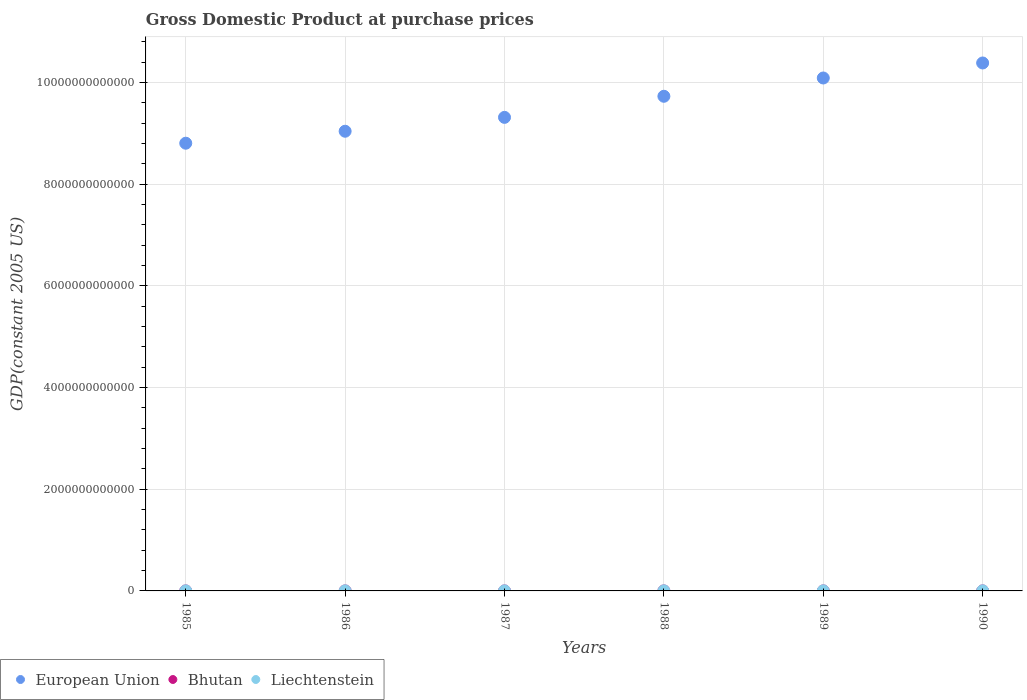What is the GDP at purchase prices in Bhutan in 1988?
Make the answer very short. 2.89e+08. Across all years, what is the maximum GDP at purchase prices in Liechtenstein?
Provide a succinct answer. 2.01e+09. Across all years, what is the minimum GDP at purchase prices in Liechtenstein?
Provide a succinct answer. 1.56e+09. In which year was the GDP at purchase prices in European Union minimum?
Make the answer very short. 1985. What is the total GDP at purchase prices in European Union in the graph?
Provide a short and direct response. 5.74e+13. What is the difference between the GDP at purchase prices in European Union in 1985 and that in 1988?
Provide a short and direct response. -9.23e+11. What is the difference between the GDP at purchase prices in Liechtenstein in 1988 and the GDP at purchase prices in Bhutan in 1990?
Make the answer very short. 1.53e+09. What is the average GDP at purchase prices in Bhutan per year?
Offer a very short reply. 2.71e+08. In the year 1990, what is the difference between the GDP at purchase prices in Bhutan and GDP at purchase prices in Liechtenstein?
Keep it short and to the point. -1.66e+09. What is the ratio of the GDP at purchase prices in Bhutan in 1985 to that in 1987?
Ensure brevity in your answer.  0.7. What is the difference between the highest and the second highest GDP at purchase prices in Liechtenstein?
Provide a succinct answer. 4.42e+07. What is the difference between the highest and the lowest GDP at purchase prices in European Union?
Your answer should be compact. 1.58e+12. In how many years, is the GDP at purchase prices in European Union greater than the average GDP at purchase prices in European Union taken over all years?
Keep it short and to the point. 3. Is the sum of the GDP at purchase prices in Liechtenstein in 1985 and 1988 greater than the maximum GDP at purchase prices in Bhutan across all years?
Your answer should be compact. Yes. Is the GDP at purchase prices in Bhutan strictly greater than the GDP at purchase prices in European Union over the years?
Make the answer very short. No. Is the GDP at purchase prices in European Union strictly less than the GDP at purchase prices in Bhutan over the years?
Your answer should be very brief. No. How many dotlines are there?
Give a very brief answer. 3. What is the difference between two consecutive major ticks on the Y-axis?
Your response must be concise. 2.00e+12. Are the values on the major ticks of Y-axis written in scientific E-notation?
Offer a very short reply. No. Does the graph contain any zero values?
Give a very brief answer. No. Does the graph contain grids?
Offer a terse response. Yes. Where does the legend appear in the graph?
Offer a very short reply. Bottom left. How many legend labels are there?
Your answer should be compact. 3. What is the title of the graph?
Your answer should be very brief. Gross Domestic Product at purchase prices. Does "Cambodia" appear as one of the legend labels in the graph?
Provide a short and direct response. No. What is the label or title of the X-axis?
Give a very brief answer. Years. What is the label or title of the Y-axis?
Make the answer very short. GDP(constant 2005 US). What is the GDP(constant 2005 US) of European Union in 1985?
Keep it short and to the point. 8.80e+12. What is the GDP(constant 2005 US) of Bhutan in 1985?
Provide a succinct answer. 1.92e+08. What is the GDP(constant 2005 US) in Liechtenstein in 1985?
Make the answer very short. 1.56e+09. What is the GDP(constant 2005 US) of European Union in 1986?
Offer a terse response. 9.04e+12. What is the GDP(constant 2005 US) of Bhutan in 1986?
Offer a terse response. 2.14e+08. What is the GDP(constant 2005 US) in Liechtenstein in 1986?
Make the answer very short. 1.63e+09. What is the GDP(constant 2005 US) in European Union in 1987?
Ensure brevity in your answer.  9.31e+12. What is the GDP(constant 2005 US) in Bhutan in 1987?
Ensure brevity in your answer.  2.75e+08. What is the GDP(constant 2005 US) of Liechtenstein in 1987?
Ensure brevity in your answer.  1.78e+09. What is the GDP(constant 2005 US) in European Union in 1988?
Ensure brevity in your answer.  9.73e+12. What is the GDP(constant 2005 US) of Bhutan in 1988?
Provide a short and direct response. 2.89e+08. What is the GDP(constant 2005 US) of Liechtenstein in 1988?
Ensure brevity in your answer.  1.88e+09. What is the GDP(constant 2005 US) in European Union in 1989?
Keep it short and to the point. 1.01e+13. What is the GDP(constant 2005 US) of Bhutan in 1989?
Give a very brief answer. 3.11e+08. What is the GDP(constant 2005 US) in Liechtenstein in 1989?
Your response must be concise. 1.96e+09. What is the GDP(constant 2005 US) of European Union in 1990?
Your answer should be very brief. 1.04e+13. What is the GDP(constant 2005 US) of Bhutan in 1990?
Offer a terse response. 3.45e+08. What is the GDP(constant 2005 US) in Liechtenstein in 1990?
Provide a succinct answer. 2.01e+09. Across all years, what is the maximum GDP(constant 2005 US) of European Union?
Make the answer very short. 1.04e+13. Across all years, what is the maximum GDP(constant 2005 US) of Bhutan?
Your answer should be very brief. 3.45e+08. Across all years, what is the maximum GDP(constant 2005 US) of Liechtenstein?
Offer a terse response. 2.01e+09. Across all years, what is the minimum GDP(constant 2005 US) in European Union?
Keep it short and to the point. 8.80e+12. Across all years, what is the minimum GDP(constant 2005 US) of Bhutan?
Your answer should be very brief. 1.92e+08. Across all years, what is the minimum GDP(constant 2005 US) in Liechtenstein?
Your response must be concise. 1.56e+09. What is the total GDP(constant 2005 US) of European Union in the graph?
Your answer should be compact. 5.74e+13. What is the total GDP(constant 2005 US) in Bhutan in the graph?
Ensure brevity in your answer.  1.63e+09. What is the total GDP(constant 2005 US) of Liechtenstein in the graph?
Your answer should be compact. 1.08e+1. What is the difference between the GDP(constant 2005 US) in European Union in 1985 and that in 1986?
Provide a short and direct response. -2.35e+11. What is the difference between the GDP(constant 2005 US) in Bhutan in 1985 and that in 1986?
Keep it short and to the point. -2.25e+07. What is the difference between the GDP(constant 2005 US) in Liechtenstein in 1985 and that in 1986?
Offer a very short reply. -6.26e+07. What is the difference between the GDP(constant 2005 US) in European Union in 1985 and that in 1987?
Make the answer very short. -5.08e+11. What is the difference between the GDP(constant 2005 US) of Bhutan in 1985 and that in 1987?
Your answer should be very brief. -8.39e+07. What is the difference between the GDP(constant 2005 US) in Liechtenstein in 1985 and that in 1987?
Keep it short and to the point. -2.13e+08. What is the difference between the GDP(constant 2005 US) in European Union in 1985 and that in 1988?
Provide a short and direct response. -9.23e+11. What is the difference between the GDP(constant 2005 US) of Bhutan in 1985 and that in 1988?
Ensure brevity in your answer.  -9.76e+07. What is the difference between the GDP(constant 2005 US) of Liechtenstein in 1985 and that in 1988?
Offer a terse response. -3.13e+08. What is the difference between the GDP(constant 2005 US) of European Union in 1985 and that in 1989?
Make the answer very short. -1.28e+12. What is the difference between the GDP(constant 2005 US) of Bhutan in 1985 and that in 1989?
Offer a terse response. -1.19e+08. What is the difference between the GDP(constant 2005 US) in Liechtenstein in 1985 and that in 1989?
Offer a terse response. -3.97e+08. What is the difference between the GDP(constant 2005 US) of European Union in 1985 and that in 1990?
Your answer should be compact. -1.58e+12. What is the difference between the GDP(constant 2005 US) of Bhutan in 1985 and that in 1990?
Your response must be concise. -1.53e+08. What is the difference between the GDP(constant 2005 US) of Liechtenstein in 1985 and that in 1990?
Offer a terse response. -4.41e+08. What is the difference between the GDP(constant 2005 US) of European Union in 1986 and that in 1987?
Give a very brief answer. -2.73e+11. What is the difference between the GDP(constant 2005 US) in Bhutan in 1986 and that in 1987?
Offer a very short reply. -6.14e+07. What is the difference between the GDP(constant 2005 US) of Liechtenstein in 1986 and that in 1987?
Keep it short and to the point. -1.50e+08. What is the difference between the GDP(constant 2005 US) of European Union in 1986 and that in 1988?
Offer a terse response. -6.88e+11. What is the difference between the GDP(constant 2005 US) of Bhutan in 1986 and that in 1988?
Offer a terse response. -7.52e+07. What is the difference between the GDP(constant 2005 US) in Liechtenstein in 1986 and that in 1988?
Make the answer very short. -2.50e+08. What is the difference between the GDP(constant 2005 US) in European Union in 1986 and that in 1989?
Your answer should be very brief. -1.05e+12. What is the difference between the GDP(constant 2005 US) in Bhutan in 1986 and that in 1989?
Your response must be concise. -9.67e+07. What is the difference between the GDP(constant 2005 US) in Liechtenstein in 1986 and that in 1989?
Your answer should be compact. -3.35e+08. What is the difference between the GDP(constant 2005 US) in European Union in 1986 and that in 1990?
Make the answer very short. -1.34e+12. What is the difference between the GDP(constant 2005 US) in Bhutan in 1986 and that in 1990?
Keep it short and to the point. -1.30e+08. What is the difference between the GDP(constant 2005 US) of Liechtenstein in 1986 and that in 1990?
Your response must be concise. -3.79e+08. What is the difference between the GDP(constant 2005 US) of European Union in 1987 and that in 1988?
Keep it short and to the point. -4.15e+11. What is the difference between the GDP(constant 2005 US) in Bhutan in 1987 and that in 1988?
Keep it short and to the point. -1.37e+07. What is the difference between the GDP(constant 2005 US) in Liechtenstein in 1987 and that in 1988?
Offer a terse response. -1.00e+08. What is the difference between the GDP(constant 2005 US) of European Union in 1987 and that in 1989?
Offer a terse response. -7.74e+11. What is the difference between the GDP(constant 2005 US) in Bhutan in 1987 and that in 1989?
Provide a succinct answer. -3.52e+07. What is the difference between the GDP(constant 2005 US) in Liechtenstein in 1987 and that in 1989?
Give a very brief answer. -1.84e+08. What is the difference between the GDP(constant 2005 US) in European Union in 1987 and that in 1990?
Offer a terse response. -1.07e+12. What is the difference between the GDP(constant 2005 US) in Bhutan in 1987 and that in 1990?
Provide a succinct answer. -6.90e+07. What is the difference between the GDP(constant 2005 US) of Liechtenstein in 1987 and that in 1990?
Ensure brevity in your answer.  -2.29e+08. What is the difference between the GDP(constant 2005 US) in European Union in 1988 and that in 1989?
Provide a succinct answer. -3.60e+11. What is the difference between the GDP(constant 2005 US) of Bhutan in 1988 and that in 1989?
Make the answer very short. -2.15e+07. What is the difference between the GDP(constant 2005 US) of Liechtenstein in 1988 and that in 1989?
Your response must be concise. -8.43e+07. What is the difference between the GDP(constant 2005 US) of European Union in 1988 and that in 1990?
Offer a very short reply. -6.55e+11. What is the difference between the GDP(constant 2005 US) of Bhutan in 1988 and that in 1990?
Provide a short and direct response. -5.53e+07. What is the difference between the GDP(constant 2005 US) of Liechtenstein in 1988 and that in 1990?
Your response must be concise. -1.28e+08. What is the difference between the GDP(constant 2005 US) in European Union in 1989 and that in 1990?
Offer a very short reply. -2.95e+11. What is the difference between the GDP(constant 2005 US) of Bhutan in 1989 and that in 1990?
Your answer should be compact. -3.38e+07. What is the difference between the GDP(constant 2005 US) in Liechtenstein in 1989 and that in 1990?
Your answer should be compact. -4.42e+07. What is the difference between the GDP(constant 2005 US) in European Union in 1985 and the GDP(constant 2005 US) in Bhutan in 1986?
Ensure brevity in your answer.  8.80e+12. What is the difference between the GDP(constant 2005 US) in European Union in 1985 and the GDP(constant 2005 US) in Liechtenstein in 1986?
Your answer should be compact. 8.80e+12. What is the difference between the GDP(constant 2005 US) of Bhutan in 1985 and the GDP(constant 2005 US) of Liechtenstein in 1986?
Your response must be concise. -1.44e+09. What is the difference between the GDP(constant 2005 US) of European Union in 1985 and the GDP(constant 2005 US) of Bhutan in 1987?
Ensure brevity in your answer.  8.80e+12. What is the difference between the GDP(constant 2005 US) of European Union in 1985 and the GDP(constant 2005 US) of Liechtenstein in 1987?
Offer a terse response. 8.80e+12. What is the difference between the GDP(constant 2005 US) in Bhutan in 1985 and the GDP(constant 2005 US) in Liechtenstein in 1987?
Offer a very short reply. -1.59e+09. What is the difference between the GDP(constant 2005 US) in European Union in 1985 and the GDP(constant 2005 US) in Bhutan in 1988?
Your answer should be compact. 8.80e+12. What is the difference between the GDP(constant 2005 US) in European Union in 1985 and the GDP(constant 2005 US) in Liechtenstein in 1988?
Provide a succinct answer. 8.80e+12. What is the difference between the GDP(constant 2005 US) of Bhutan in 1985 and the GDP(constant 2005 US) of Liechtenstein in 1988?
Your answer should be very brief. -1.69e+09. What is the difference between the GDP(constant 2005 US) in European Union in 1985 and the GDP(constant 2005 US) in Bhutan in 1989?
Give a very brief answer. 8.80e+12. What is the difference between the GDP(constant 2005 US) in European Union in 1985 and the GDP(constant 2005 US) in Liechtenstein in 1989?
Offer a very short reply. 8.80e+12. What is the difference between the GDP(constant 2005 US) of Bhutan in 1985 and the GDP(constant 2005 US) of Liechtenstein in 1989?
Your response must be concise. -1.77e+09. What is the difference between the GDP(constant 2005 US) of European Union in 1985 and the GDP(constant 2005 US) of Bhutan in 1990?
Your answer should be very brief. 8.80e+12. What is the difference between the GDP(constant 2005 US) in European Union in 1985 and the GDP(constant 2005 US) in Liechtenstein in 1990?
Your answer should be compact. 8.80e+12. What is the difference between the GDP(constant 2005 US) of Bhutan in 1985 and the GDP(constant 2005 US) of Liechtenstein in 1990?
Your answer should be compact. -1.81e+09. What is the difference between the GDP(constant 2005 US) in European Union in 1986 and the GDP(constant 2005 US) in Bhutan in 1987?
Your answer should be compact. 9.04e+12. What is the difference between the GDP(constant 2005 US) in European Union in 1986 and the GDP(constant 2005 US) in Liechtenstein in 1987?
Keep it short and to the point. 9.04e+12. What is the difference between the GDP(constant 2005 US) in Bhutan in 1986 and the GDP(constant 2005 US) in Liechtenstein in 1987?
Make the answer very short. -1.56e+09. What is the difference between the GDP(constant 2005 US) in European Union in 1986 and the GDP(constant 2005 US) in Bhutan in 1988?
Your response must be concise. 9.04e+12. What is the difference between the GDP(constant 2005 US) of European Union in 1986 and the GDP(constant 2005 US) of Liechtenstein in 1988?
Give a very brief answer. 9.04e+12. What is the difference between the GDP(constant 2005 US) in Bhutan in 1986 and the GDP(constant 2005 US) in Liechtenstein in 1988?
Offer a very short reply. -1.66e+09. What is the difference between the GDP(constant 2005 US) in European Union in 1986 and the GDP(constant 2005 US) in Bhutan in 1989?
Ensure brevity in your answer.  9.04e+12. What is the difference between the GDP(constant 2005 US) in European Union in 1986 and the GDP(constant 2005 US) in Liechtenstein in 1989?
Make the answer very short. 9.04e+12. What is the difference between the GDP(constant 2005 US) of Bhutan in 1986 and the GDP(constant 2005 US) of Liechtenstein in 1989?
Your answer should be very brief. -1.75e+09. What is the difference between the GDP(constant 2005 US) of European Union in 1986 and the GDP(constant 2005 US) of Bhutan in 1990?
Offer a very short reply. 9.04e+12. What is the difference between the GDP(constant 2005 US) in European Union in 1986 and the GDP(constant 2005 US) in Liechtenstein in 1990?
Your response must be concise. 9.04e+12. What is the difference between the GDP(constant 2005 US) in Bhutan in 1986 and the GDP(constant 2005 US) in Liechtenstein in 1990?
Your answer should be compact. -1.79e+09. What is the difference between the GDP(constant 2005 US) of European Union in 1987 and the GDP(constant 2005 US) of Bhutan in 1988?
Your answer should be very brief. 9.31e+12. What is the difference between the GDP(constant 2005 US) in European Union in 1987 and the GDP(constant 2005 US) in Liechtenstein in 1988?
Offer a very short reply. 9.31e+12. What is the difference between the GDP(constant 2005 US) of Bhutan in 1987 and the GDP(constant 2005 US) of Liechtenstein in 1988?
Ensure brevity in your answer.  -1.60e+09. What is the difference between the GDP(constant 2005 US) in European Union in 1987 and the GDP(constant 2005 US) in Bhutan in 1989?
Offer a terse response. 9.31e+12. What is the difference between the GDP(constant 2005 US) of European Union in 1987 and the GDP(constant 2005 US) of Liechtenstein in 1989?
Make the answer very short. 9.31e+12. What is the difference between the GDP(constant 2005 US) of Bhutan in 1987 and the GDP(constant 2005 US) of Liechtenstein in 1989?
Ensure brevity in your answer.  -1.69e+09. What is the difference between the GDP(constant 2005 US) of European Union in 1987 and the GDP(constant 2005 US) of Bhutan in 1990?
Give a very brief answer. 9.31e+12. What is the difference between the GDP(constant 2005 US) in European Union in 1987 and the GDP(constant 2005 US) in Liechtenstein in 1990?
Provide a short and direct response. 9.31e+12. What is the difference between the GDP(constant 2005 US) of Bhutan in 1987 and the GDP(constant 2005 US) of Liechtenstein in 1990?
Offer a terse response. -1.73e+09. What is the difference between the GDP(constant 2005 US) of European Union in 1988 and the GDP(constant 2005 US) of Bhutan in 1989?
Your answer should be compact. 9.73e+12. What is the difference between the GDP(constant 2005 US) of European Union in 1988 and the GDP(constant 2005 US) of Liechtenstein in 1989?
Ensure brevity in your answer.  9.73e+12. What is the difference between the GDP(constant 2005 US) of Bhutan in 1988 and the GDP(constant 2005 US) of Liechtenstein in 1989?
Offer a very short reply. -1.67e+09. What is the difference between the GDP(constant 2005 US) in European Union in 1988 and the GDP(constant 2005 US) in Bhutan in 1990?
Your answer should be compact. 9.73e+12. What is the difference between the GDP(constant 2005 US) in European Union in 1988 and the GDP(constant 2005 US) in Liechtenstein in 1990?
Keep it short and to the point. 9.73e+12. What is the difference between the GDP(constant 2005 US) in Bhutan in 1988 and the GDP(constant 2005 US) in Liechtenstein in 1990?
Your answer should be very brief. -1.72e+09. What is the difference between the GDP(constant 2005 US) of European Union in 1989 and the GDP(constant 2005 US) of Bhutan in 1990?
Your answer should be very brief. 1.01e+13. What is the difference between the GDP(constant 2005 US) of European Union in 1989 and the GDP(constant 2005 US) of Liechtenstein in 1990?
Give a very brief answer. 1.01e+13. What is the difference between the GDP(constant 2005 US) of Bhutan in 1989 and the GDP(constant 2005 US) of Liechtenstein in 1990?
Provide a succinct answer. -1.69e+09. What is the average GDP(constant 2005 US) of European Union per year?
Your answer should be compact. 9.56e+12. What is the average GDP(constant 2005 US) in Bhutan per year?
Make the answer very short. 2.71e+08. What is the average GDP(constant 2005 US) of Liechtenstein per year?
Ensure brevity in your answer.  1.80e+09. In the year 1985, what is the difference between the GDP(constant 2005 US) in European Union and GDP(constant 2005 US) in Bhutan?
Offer a terse response. 8.80e+12. In the year 1985, what is the difference between the GDP(constant 2005 US) in European Union and GDP(constant 2005 US) in Liechtenstein?
Provide a short and direct response. 8.80e+12. In the year 1985, what is the difference between the GDP(constant 2005 US) of Bhutan and GDP(constant 2005 US) of Liechtenstein?
Ensure brevity in your answer.  -1.37e+09. In the year 1986, what is the difference between the GDP(constant 2005 US) in European Union and GDP(constant 2005 US) in Bhutan?
Keep it short and to the point. 9.04e+12. In the year 1986, what is the difference between the GDP(constant 2005 US) in European Union and GDP(constant 2005 US) in Liechtenstein?
Your answer should be very brief. 9.04e+12. In the year 1986, what is the difference between the GDP(constant 2005 US) in Bhutan and GDP(constant 2005 US) in Liechtenstein?
Your response must be concise. -1.41e+09. In the year 1987, what is the difference between the GDP(constant 2005 US) of European Union and GDP(constant 2005 US) of Bhutan?
Provide a succinct answer. 9.31e+12. In the year 1987, what is the difference between the GDP(constant 2005 US) in European Union and GDP(constant 2005 US) in Liechtenstein?
Make the answer very short. 9.31e+12. In the year 1987, what is the difference between the GDP(constant 2005 US) in Bhutan and GDP(constant 2005 US) in Liechtenstein?
Keep it short and to the point. -1.50e+09. In the year 1988, what is the difference between the GDP(constant 2005 US) of European Union and GDP(constant 2005 US) of Bhutan?
Your answer should be compact. 9.73e+12. In the year 1988, what is the difference between the GDP(constant 2005 US) in European Union and GDP(constant 2005 US) in Liechtenstein?
Your response must be concise. 9.73e+12. In the year 1988, what is the difference between the GDP(constant 2005 US) in Bhutan and GDP(constant 2005 US) in Liechtenstein?
Offer a very short reply. -1.59e+09. In the year 1989, what is the difference between the GDP(constant 2005 US) in European Union and GDP(constant 2005 US) in Bhutan?
Provide a short and direct response. 1.01e+13. In the year 1989, what is the difference between the GDP(constant 2005 US) of European Union and GDP(constant 2005 US) of Liechtenstein?
Make the answer very short. 1.01e+13. In the year 1989, what is the difference between the GDP(constant 2005 US) in Bhutan and GDP(constant 2005 US) in Liechtenstein?
Give a very brief answer. -1.65e+09. In the year 1990, what is the difference between the GDP(constant 2005 US) of European Union and GDP(constant 2005 US) of Bhutan?
Keep it short and to the point. 1.04e+13. In the year 1990, what is the difference between the GDP(constant 2005 US) of European Union and GDP(constant 2005 US) of Liechtenstein?
Your answer should be compact. 1.04e+13. In the year 1990, what is the difference between the GDP(constant 2005 US) of Bhutan and GDP(constant 2005 US) of Liechtenstein?
Keep it short and to the point. -1.66e+09. What is the ratio of the GDP(constant 2005 US) in Bhutan in 1985 to that in 1986?
Your response must be concise. 0.9. What is the ratio of the GDP(constant 2005 US) in Liechtenstein in 1985 to that in 1986?
Your answer should be very brief. 0.96. What is the ratio of the GDP(constant 2005 US) in European Union in 1985 to that in 1987?
Provide a succinct answer. 0.95. What is the ratio of the GDP(constant 2005 US) in Bhutan in 1985 to that in 1987?
Give a very brief answer. 0.7. What is the ratio of the GDP(constant 2005 US) in Liechtenstein in 1985 to that in 1987?
Your response must be concise. 0.88. What is the ratio of the GDP(constant 2005 US) of European Union in 1985 to that in 1988?
Your response must be concise. 0.91. What is the ratio of the GDP(constant 2005 US) in Bhutan in 1985 to that in 1988?
Offer a terse response. 0.66. What is the ratio of the GDP(constant 2005 US) of European Union in 1985 to that in 1989?
Keep it short and to the point. 0.87. What is the ratio of the GDP(constant 2005 US) of Bhutan in 1985 to that in 1989?
Offer a very short reply. 0.62. What is the ratio of the GDP(constant 2005 US) in Liechtenstein in 1985 to that in 1989?
Ensure brevity in your answer.  0.8. What is the ratio of the GDP(constant 2005 US) in European Union in 1985 to that in 1990?
Keep it short and to the point. 0.85. What is the ratio of the GDP(constant 2005 US) of Bhutan in 1985 to that in 1990?
Provide a short and direct response. 0.56. What is the ratio of the GDP(constant 2005 US) of Liechtenstein in 1985 to that in 1990?
Offer a terse response. 0.78. What is the ratio of the GDP(constant 2005 US) of European Union in 1986 to that in 1987?
Your answer should be compact. 0.97. What is the ratio of the GDP(constant 2005 US) of Bhutan in 1986 to that in 1987?
Offer a very short reply. 0.78. What is the ratio of the GDP(constant 2005 US) of Liechtenstein in 1986 to that in 1987?
Make the answer very short. 0.92. What is the ratio of the GDP(constant 2005 US) of European Union in 1986 to that in 1988?
Your answer should be very brief. 0.93. What is the ratio of the GDP(constant 2005 US) of Bhutan in 1986 to that in 1988?
Offer a terse response. 0.74. What is the ratio of the GDP(constant 2005 US) in Liechtenstein in 1986 to that in 1988?
Provide a short and direct response. 0.87. What is the ratio of the GDP(constant 2005 US) in European Union in 1986 to that in 1989?
Give a very brief answer. 0.9. What is the ratio of the GDP(constant 2005 US) of Bhutan in 1986 to that in 1989?
Offer a terse response. 0.69. What is the ratio of the GDP(constant 2005 US) in Liechtenstein in 1986 to that in 1989?
Give a very brief answer. 0.83. What is the ratio of the GDP(constant 2005 US) in European Union in 1986 to that in 1990?
Your answer should be compact. 0.87. What is the ratio of the GDP(constant 2005 US) of Bhutan in 1986 to that in 1990?
Offer a terse response. 0.62. What is the ratio of the GDP(constant 2005 US) of Liechtenstein in 1986 to that in 1990?
Make the answer very short. 0.81. What is the ratio of the GDP(constant 2005 US) of European Union in 1987 to that in 1988?
Offer a very short reply. 0.96. What is the ratio of the GDP(constant 2005 US) of Bhutan in 1987 to that in 1988?
Your response must be concise. 0.95. What is the ratio of the GDP(constant 2005 US) in Liechtenstein in 1987 to that in 1988?
Provide a short and direct response. 0.95. What is the ratio of the GDP(constant 2005 US) in European Union in 1987 to that in 1989?
Make the answer very short. 0.92. What is the ratio of the GDP(constant 2005 US) in Bhutan in 1987 to that in 1989?
Your answer should be compact. 0.89. What is the ratio of the GDP(constant 2005 US) in Liechtenstein in 1987 to that in 1989?
Make the answer very short. 0.91. What is the ratio of the GDP(constant 2005 US) of European Union in 1987 to that in 1990?
Make the answer very short. 0.9. What is the ratio of the GDP(constant 2005 US) of Bhutan in 1987 to that in 1990?
Provide a short and direct response. 0.8. What is the ratio of the GDP(constant 2005 US) in Liechtenstein in 1987 to that in 1990?
Keep it short and to the point. 0.89. What is the ratio of the GDP(constant 2005 US) in European Union in 1988 to that in 1989?
Give a very brief answer. 0.96. What is the ratio of the GDP(constant 2005 US) of Bhutan in 1988 to that in 1989?
Your answer should be very brief. 0.93. What is the ratio of the GDP(constant 2005 US) of Liechtenstein in 1988 to that in 1989?
Offer a very short reply. 0.96. What is the ratio of the GDP(constant 2005 US) of European Union in 1988 to that in 1990?
Ensure brevity in your answer.  0.94. What is the ratio of the GDP(constant 2005 US) of Bhutan in 1988 to that in 1990?
Offer a very short reply. 0.84. What is the ratio of the GDP(constant 2005 US) in Liechtenstein in 1988 to that in 1990?
Ensure brevity in your answer.  0.94. What is the ratio of the GDP(constant 2005 US) of European Union in 1989 to that in 1990?
Provide a succinct answer. 0.97. What is the ratio of the GDP(constant 2005 US) in Bhutan in 1989 to that in 1990?
Offer a very short reply. 0.9. What is the difference between the highest and the second highest GDP(constant 2005 US) in European Union?
Provide a short and direct response. 2.95e+11. What is the difference between the highest and the second highest GDP(constant 2005 US) in Bhutan?
Offer a terse response. 3.38e+07. What is the difference between the highest and the second highest GDP(constant 2005 US) of Liechtenstein?
Offer a very short reply. 4.42e+07. What is the difference between the highest and the lowest GDP(constant 2005 US) in European Union?
Your answer should be compact. 1.58e+12. What is the difference between the highest and the lowest GDP(constant 2005 US) of Bhutan?
Provide a short and direct response. 1.53e+08. What is the difference between the highest and the lowest GDP(constant 2005 US) of Liechtenstein?
Ensure brevity in your answer.  4.41e+08. 